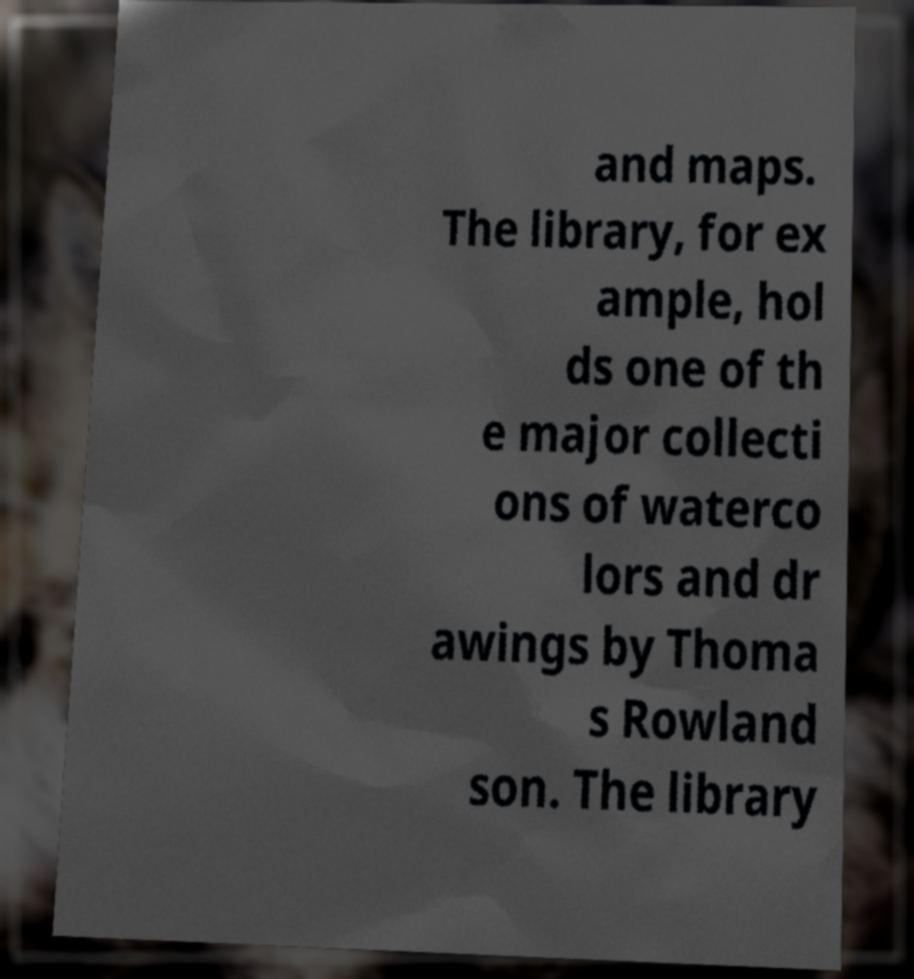What messages or text are displayed in this image? I need them in a readable, typed format. and maps. The library, for ex ample, hol ds one of th e major collecti ons of waterco lors and dr awings by Thoma s Rowland son. The library 